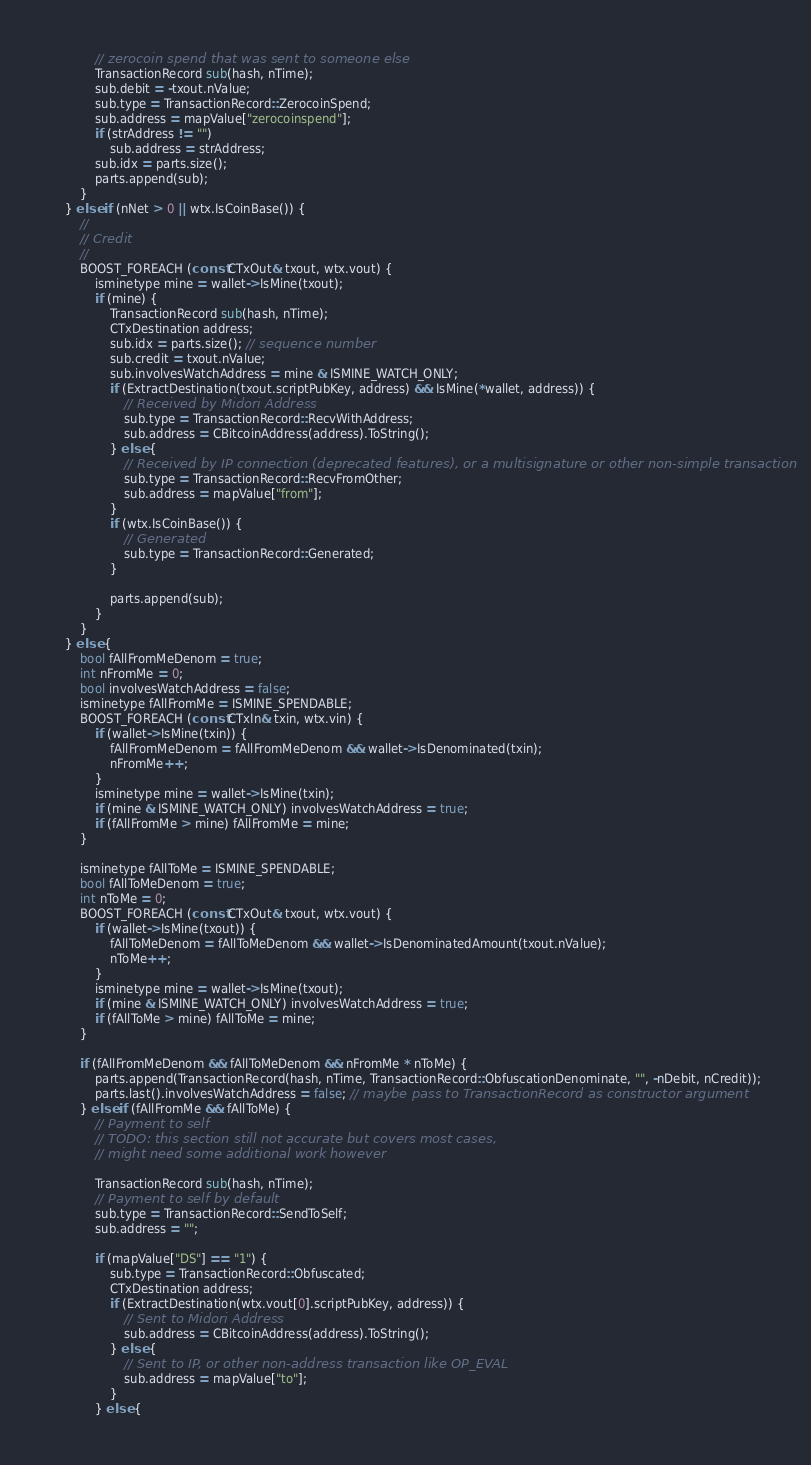<code> <loc_0><loc_0><loc_500><loc_500><_C++_>            // zerocoin spend that was sent to someone else
            TransactionRecord sub(hash, nTime);
            sub.debit = -txout.nValue;
            sub.type = TransactionRecord::ZerocoinSpend;
            sub.address = mapValue["zerocoinspend"];
            if (strAddress != "")
                sub.address = strAddress;
            sub.idx = parts.size();
            parts.append(sub);
        }
    } else if (nNet > 0 || wtx.IsCoinBase()) {
        //
        // Credit
        //
        BOOST_FOREACH (const CTxOut& txout, wtx.vout) {
            isminetype mine = wallet->IsMine(txout);
            if (mine) {
                TransactionRecord sub(hash, nTime);
                CTxDestination address;
                sub.idx = parts.size(); // sequence number
                sub.credit = txout.nValue;
                sub.involvesWatchAddress = mine & ISMINE_WATCH_ONLY;
                if (ExtractDestination(txout.scriptPubKey, address) && IsMine(*wallet, address)) {
                    // Received by Midori Address
                    sub.type = TransactionRecord::RecvWithAddress;
                    sub.address = CBitcoinAddress(address).ToString();
                } else {
                    // Received by IP connection (deprecated features), or a multisignature or other non-simple transaction
                    sub.type = TransactionRecord::RecvFromOther;
                    sub.address = mapValue["from"];
                }
                if (wtx.IsCoinBase()) {
                    // Generated
                    sub.type = TransactionRecord::Generated;
                }

                parts.append(sub);
            }
        }
    } else {
        bool fAllFromMeDenom = true;
        int nFromMe = 0;
        bool involvesWatchAddress = false;
        isminetype fAllFromMe = ISMINE_SPENDABLE;
        BOOST_FOREACH (const CTxIn& txin, wtx.vin) {
            if (wallet->IsMine(txin)) {
                fAllFromMeDenom = fAllFromMeDenom && wallet->IsDenominated(txin);
                nFromMe++;
            }
            isminetype mine = wallet->IsMine(txin);
            if (mine & ISMINE_WATCH_ONLY) involvesWatchAddress = true;
            if (fAllFromMe > mine) fAllFromMe = mine;
        }

        isminetype fAllToMe = ISMINE_SPENDABLE;
        bool fAllToMeDenom = true;
        int nToMe = 0;
        BOOST_FOREACH (const CTxOut& txout, wtx.vout) {
            if (wallet->IsMine(txout)) {
                fAllToMeDenom = fAllToMeDenom && wallet->IsDenominatedAmount(txout.nValue);
                nToMe++;
            }
            isminetype mine = wallet->IsMine(txout);
            if (mine & ISMINE_WATCH_ONLY) involvesWatchAddress = true;
            if (fAllToMe > mine) fAllToMe = mine;
        }

        if (fAllFromMeDenom && fAllToMeDenom && nFromMe * nToMe) {
            parts.append(TransactionRecord(hash, nTime, TransactionRecord::ObfuscationDenominate, "", -nDebit, nCredit));
            parts.last().involvesWatchAddress = false; // maybe pass to TransactionRecord as constructor argument
        } else if (fAllFromMe && fAllToMe) {
            // Payment to self
            // TODO: this section still not accurate but covers most cases,
            // might need some additional work however

            TransactionRecord sub(hash, nTime);
            // Payment to self by default
            sub.type = TransactionRecord::SendToSelf;
            sub.address = "";

            if (mapValue["DS"] == "1") {
                sub.type = TransactionRecord::Obfuscated;
                CTxDestination address;
                if (ExtractDestination(wtx.vout[0].scriptPubKey, address)) {
                    // Sent to Midori Address
                    sub.address = CBitcoinAddress(address).ToString();
                } else {
                    // Sent to IP, or other non-address transaction like OP_EVAL
                    sub.address = mapValue["to"];
                }
            } else {</code> 